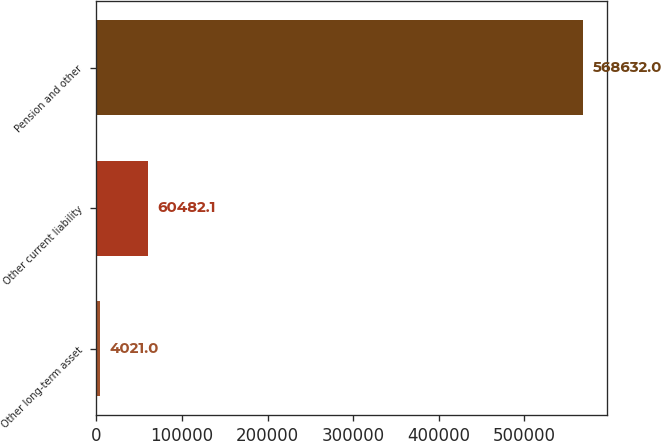Convert chart. <chart><loc_0><loc_0><loc_500><loc_500><bar_chart><fcel>Other long-term asset<fcel>Other current liability<fcel>Pension and other<nl><fcel>4021<fcel>60482.1<fcel>568632<nl></chart> 